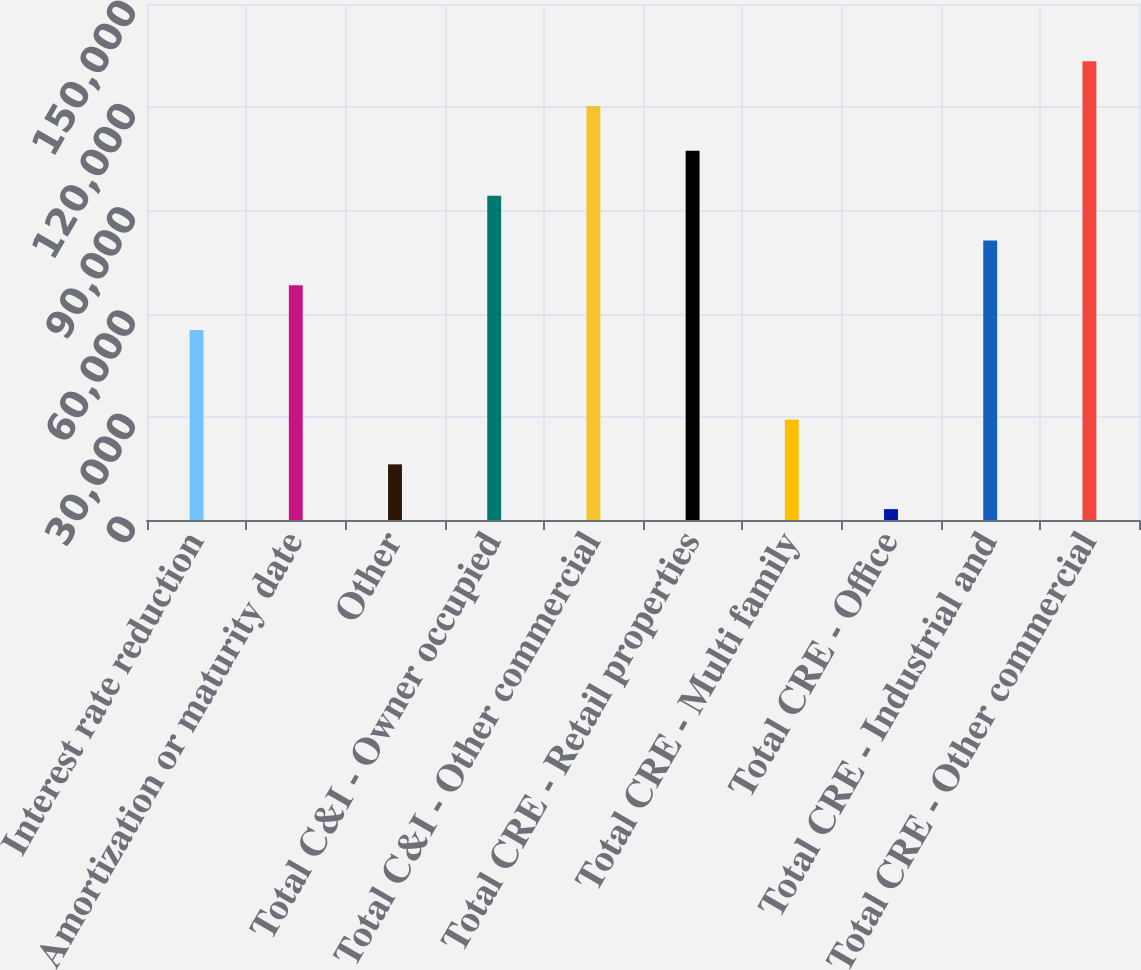<chart> <loc_0><loc_0><loc_500><loc_500><bar_chart><fcel>Interest rate reduction<fcel>Amortization or maturity date<fcel>Other<fcel>Total C&I - Owner occupied<fcel>Total C&I - Other commercial<fcel>Total CRE - Retail properties<fcel>Total CRE - Multi family<fcel>Total CRE - Office<fcel>Total CRE - Industrial and<fcel>Total CRE - Other commercial<nl><fcel>55237<fcel>68256<fcel>16180<fcel>94294<fcel>120332<fcel>107313<fcel>29199<fcel>3161<fcel>81275<fcel>133351<nl></chart> 